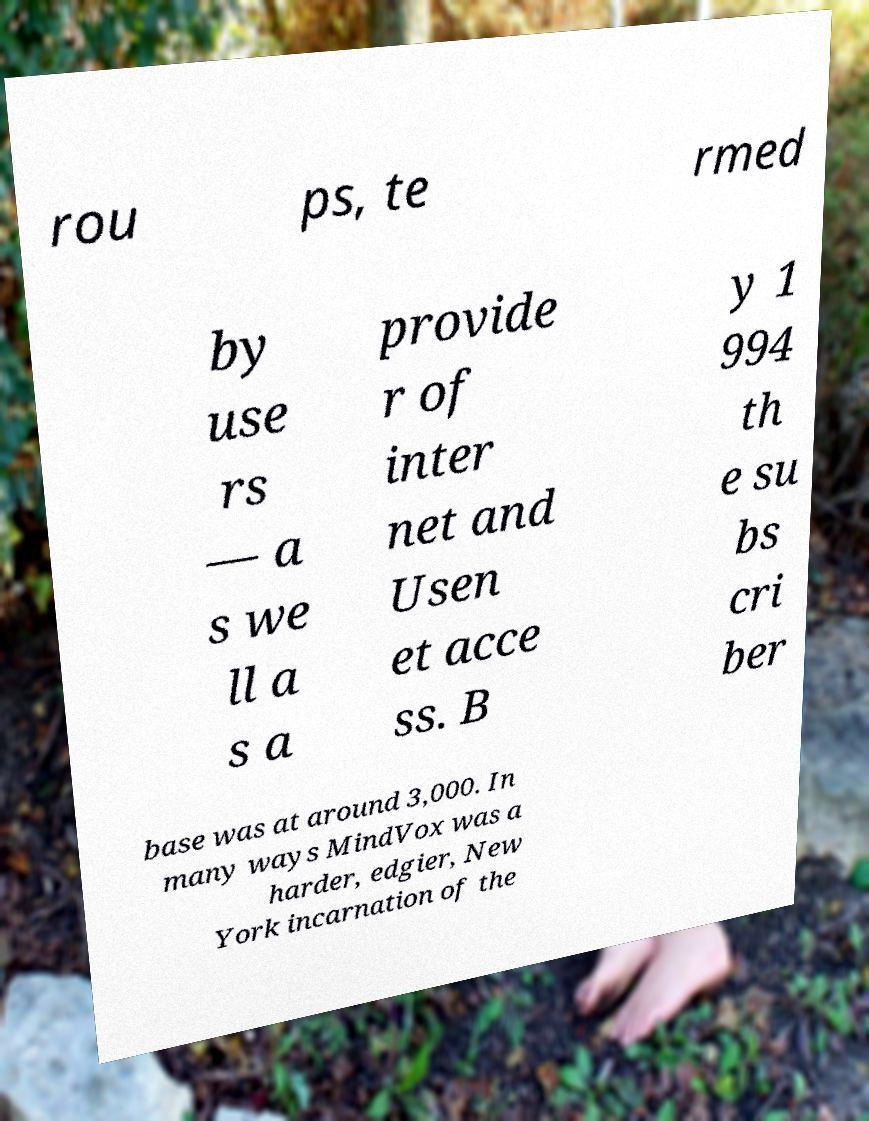Please read and relay the text visible in this image. What does it say? rou ps, te rmed by use rs — a s we ll a s a provide r of inter net and Usen et acce ss. B y 1 994 th e su bs cri ber base was at around 3,000. In many ways MindVox was a harder, edgier, New York incarnation of the 